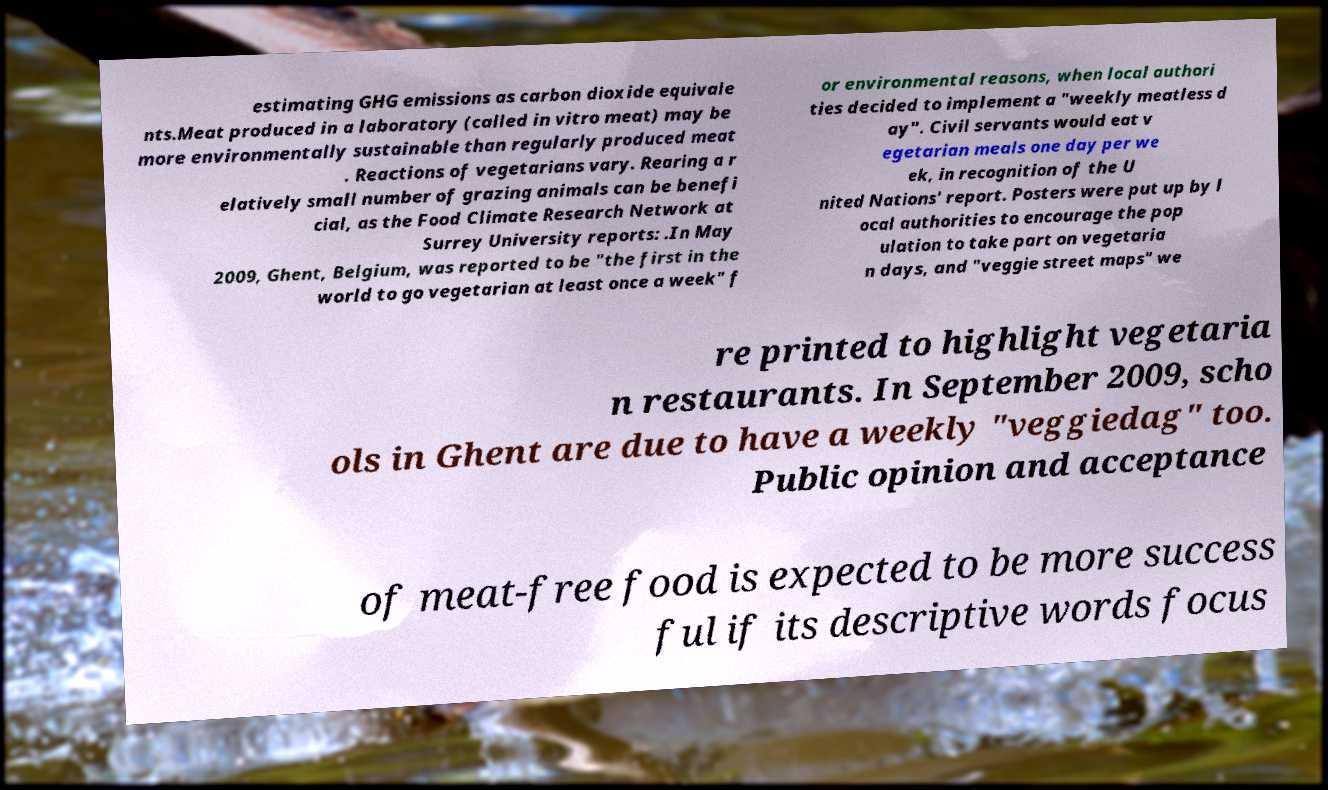There's text embedded in this image that I need extracted. Can you transcribe it verbatim? estimating GHG emissions as carbon dioxide equivale nts.Meat produced in a laboratory (called in vitro meat) may be more environmentally sustainable than regularly produced meat . Reactions of vegetarians vary. Rearing a r elatively small number of grazing animals can be benefi cial, as the Food Climate Research Network at Surrey University reports: .In May 2009, Ghent, Belgium, was reported to be "the first in the world to go vegetarian at least once a week" f or environmental reasons, when local authori ties decided to implement a "weekly meatless d ay". Civil servants would eat v egetarian meals one day per we ek, in recognition of the U nited Nations' report. Posters were put up by l ocal authorities to encourage the pop ulation to take part on vegetaria n days, and "veggie street maps" we re printed to highlight vegetaria n restaurants. In September 2009, scho ols in Ghent are due to have a weekly "veggiedag" too. Public opinion and acceptance of meat-free food is expected to be more success ful if its descriptive words focus 